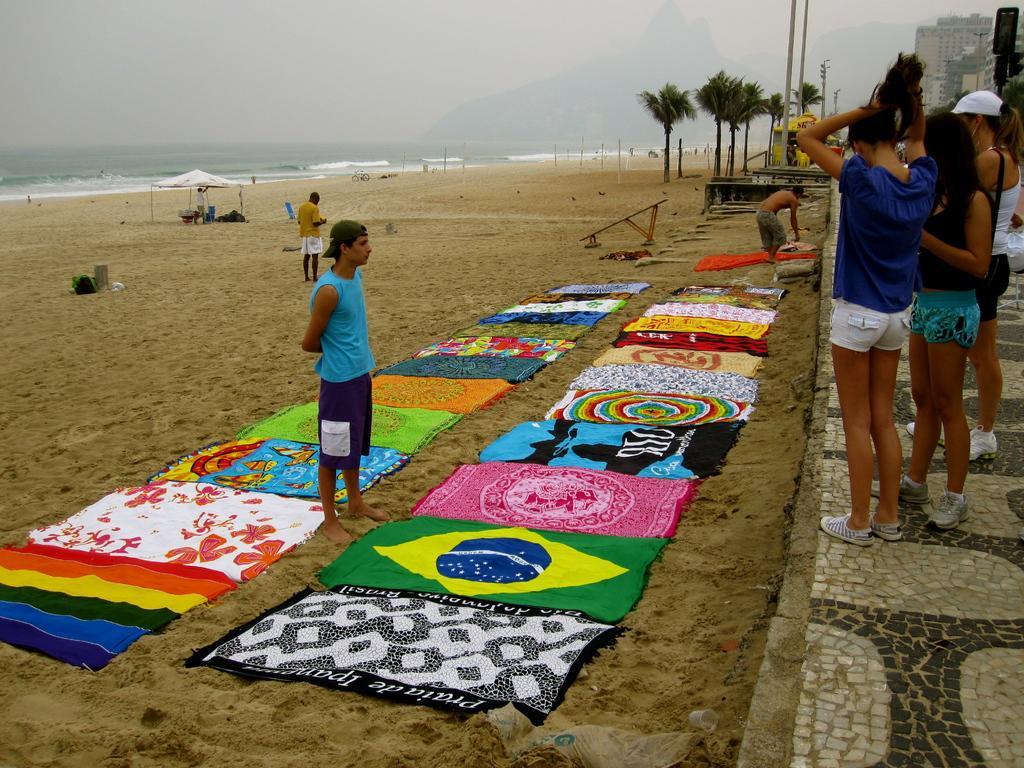Can you describe this image briefly? In this picture I can see buildings and few people standing on the sidewalk and I can see few of them standing on the ground and I can see clothes on the ground and I can see a man standing under the tent and I can see water and a hill and few trees. 